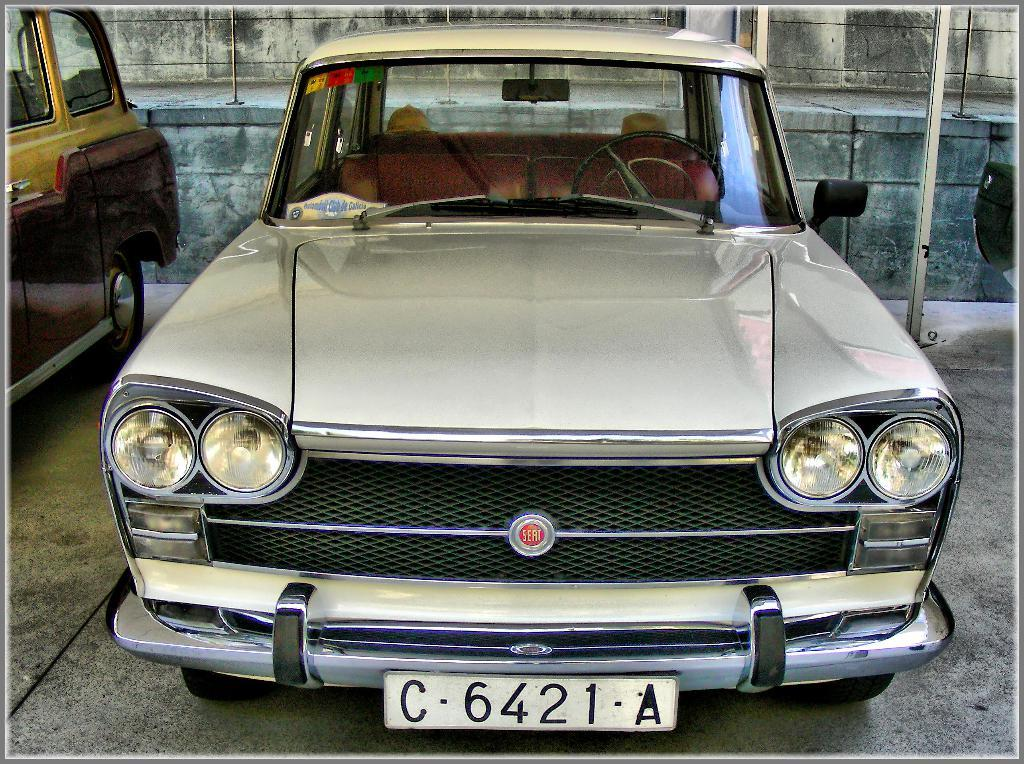What can be seen on the ground in the image? There are two vehicles on the ground in the image. What is visible in the background of the image? There is a wall and poles in the background of the image. Can you describe the object on the right side of the image? Unfortunately, the facts provided do not give enough information to describe the object on the right side of the image. How does the dust affect the motion of the vehicles in the image? There is no mention of dust in the image, so it cannot affect the motion of the vehicles. 